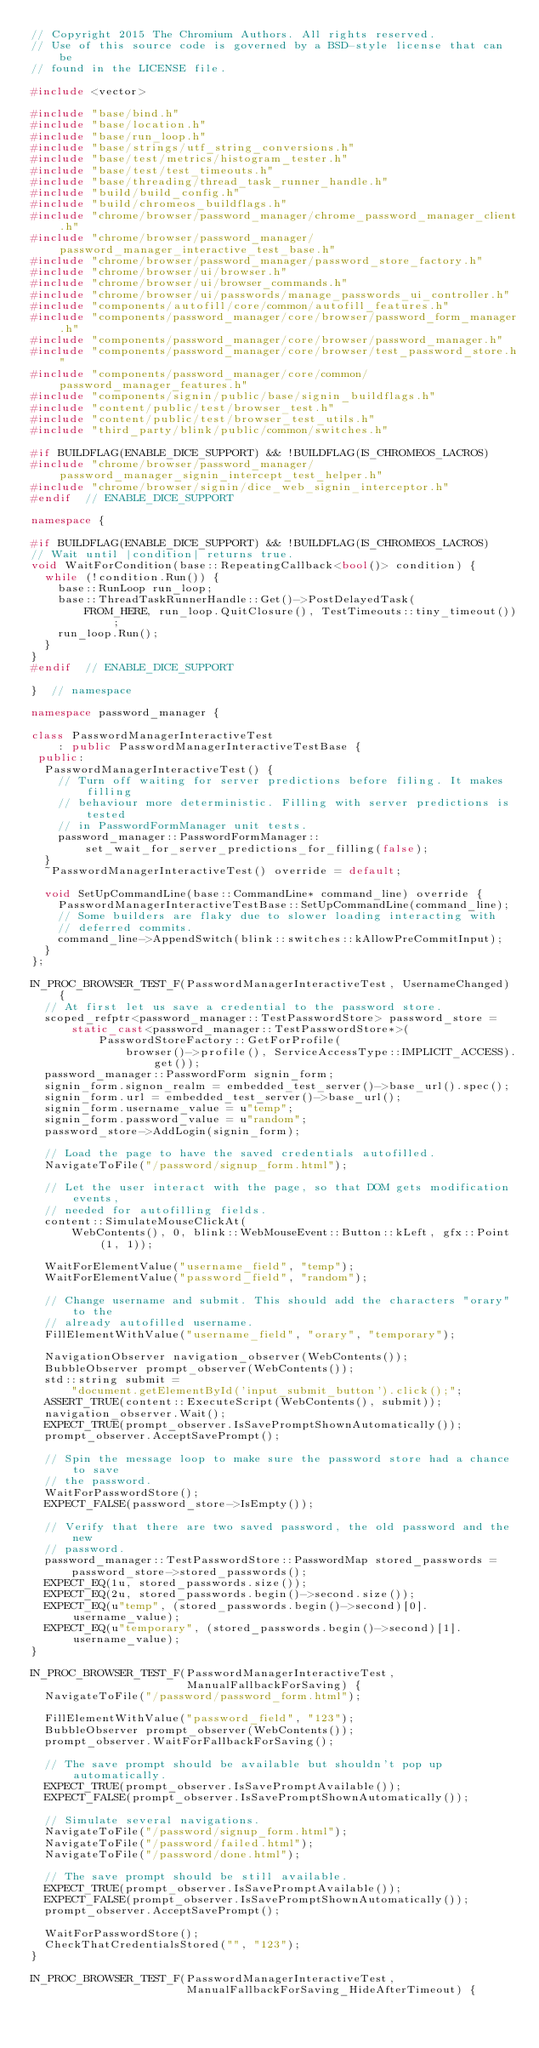<code> <loc_0><loc_0><loc_500><loc_500><_C++_>// Copyright 2015 The Chromium Authors. All rights reserved.
// Use of this source code is governed by a BSD-style license that can be
// found in the LICENSE file.

#include <vector>

#include "base/bind.h"
#include "base/location.h"
#include "base/run_loop.h"
#include "base/strings/utf_string_conversions.h"
#include "base/test/metrics/histogram_tester.h"
#include "base/test/test_timeouts.h"
#include "base/threading/thread_task_runner_handle.h"
#include "build/build_config.h"
#include "build/chromeos_buildflags.h"
#include "chrome/browser/password_manager/chrome_password_manager_client.h"
#include "chrome/browser/password_manager/password_manager_interactive_test_base.h"
#include "chrome/browser/password_manager/password_store_factory.h"
#include "chrome/browser/ui/browser.h"
#include "chrome/browser/ui/browser_commands.h"
#include "chrome/browser/ui/passwords/manage_passwords_ui_controller.h"
#include "components/autofill/core/common/autofill_features.h"
#include "components/password_manager/core/browser/password_form_manager.h"
#include "components/password_manager/core/browser/password_manager.h"
#include "components/password_manager/core/browser/test_password_store.h"
#include "components/password_manager/core/common/password_manager_features.h"
#include "components/signin/public/base/signin_buildflags.h"
#include "content/public/test/browser_test.h"
#include "content/public/test/browser_test_utils.h"
#include "third_party/blink/public/common/switches.h"

#if BUILDFLAG(ENABLE_DICE_SUPPORT) && !BUILDFLAG(IS_CHROMEOS_LACROS)
#include "chrome/browser/password_manager/password_manager_signin_intercept_test_helper.h"
#include "chrome/browser/signin/dice_web_signin_interceptor.h"
#endif  // ENABLE_DICE_SUPPORT

namespace {

#if BUILDFLAG(ENABLE_DICE_SUPPORT) && !BUILDFLAG(IS_CHROMEOS_LACROS)
// Wait until |condition| returns true.
void WaitForCondition(base::RepeatingCallback<bool()> condition) {
  while (!condition.Run()) {
    base::RunLoop run_loop;
    base::ThreadTaskRunnerHandle::Get()->PostDelayedTask(
        FROM_HERE, run_loop.QuitClosure(), TestTimeouts::tiny_timeout());
    run_loop.Run();
  }
}
#endif  // ENABLE_DICE_SUPPORT

}  // namespace

namespace password_manager {

class PasswordManagerInteractiveTest
    : public PasswordManagerInteractiveTestBase {
 public:
  PasswordManagerInteractiveTest() {
    // Turn off waiting for server predictions before filing. It makes filling
    // behaviour more deterministic. Filling with server predictions is tested
    // in PasswordFormManager unit tests.
    password_manager::PasswordFormManager::
        set_wait_for_server_predictions_for_filling(false);
  }
  ~PasswordManagerInteractiveTest() override = default;

  void SetUpCommandLine(base::CommandLine* command_line) override {
    PasswordManagerInteractiveTestBase::SetUpCommandLine(command_line);
    // Some builders are flaky due to slower loading interacting with
    // deferred commits.
    command_line->AppendSwitch(blink::switches::kAllowPreCommitInput);
  }
};

IN_PROC_BROWSER_TEST_F(PasswordManagerInteractiveTest, UsernameChanged) {
  // At first let us save a credential to the password store.
  scoped_refptr<password_manager::TestPasswordStore> password_store =
      static_cast<password_manager::TestPasswordStore*>(
          PasswordStoreFactory::GetForProfile(
              browser()->profile(), ServiceAccessType::IMPLICIT_ACCESS).get());
  password_manager::PasswordForm signin_form;
  signin_form.signon_realm = embedded_test_server()->base_url().spec();
  signin_form.url = embedded_test_server()->base_url();
  signin_form.username_value = u"temp";
  signin_form.password_value = u"random";
  password_store->AddLogin(signin_form);

  // Load the page to have the saved credentials autofilled.
  NavigateToFile("/password/signup_form.html");

  // Let the user interact with the page, so that DOM gets modification events,
  // needed for autofilling fields.
  content::SimulateMouseClickAt(
      WebContents(), 0, blink::WebMouseEvent::Button::kLeft, gfx::Point(1, 1));

  WaitForElementValue("username_field", "temp");
  WaitForElementValue("password_field", "random");

  // Change username and submit. This should add the characters "orary" to the
  // already autofilled username.
  FillElementWithValue("username_field", "orary", "temporary");

  NavigationObserver navigation_observer(WebContents());
  BubbleObserver prompt_observer(WebContents());
  std::string submit =
      "document.getElementById('input_submit_button').click();";
  ASSERT_TRUE(content::ExecuteScript(WebContents(), submit));
  navigation_observer.Wait();
  EXPECT_TRUE(prompt_observer.IsSavePromptShownAutomatically());
  prompt_observer.AcceptSavePrompt();

  // Spin the message loop to make sure the password store had a chance to save
  // the password.
  WaitForPasswordStore();
  EXPECT_FALSE(password_store->IsEmpty());

  // Verify that there are two saved password, the old password and the new
  // password.
  password_manager::TestPasswordStore::PasswordMap stored_passwords =
      password_store->stored_passwords();
  EXPECT_EQ(1u, stored_passwords.size());
  EXPECT_EQ(2u, stored_passwords.begin()->second.size());
  EXPECT_EQ(u"temp", (stored_passwords.begin()->second)[0].username_value);
  EXPECT_EQ(u"temporary", (stored_passwords.begin()->second)[1].username_value);
}

IN_PROC_BROWSER_TEST_F(PasswordManagerInteractiveTest,
                       ManualFallbackForSaving) {
  NavigateToFile("/password/password_form.html");

  FillElementWithValue("password_field", "123");
  BubbleObserver prompt_observer(WebContents());
  prompt_observer.WaitForFallbackForSaving();

  // The save prompt should be available but shouldn't pop up automatically.
  EXPECT_TRUE(prompt_observer.IsSavePromptAvailable());
  EXPECT_FALSE(prompt_observer.IsSavePromptShownAutomatically());

  // Simulate several navigations.
  NavigateToFile("/password/signup_form.html");
  NavigateToFile("/password/failed.html");
  NavigateToFile("/password/done.html");

  // The save prompt should be still available.
  EXPECT_TRUE(prompt_observer.IsSavePromptAvailable());
  EXPECT_FALSE(prompt_observer.IsSavePromptShownAutomatically());
  prompt_observer.AcceptSavePrompt();

  WaitForPasswordStore();
  CheckThatCredentialsStored("", "123");
}

IN_PROC_BROWSER_TEST_F(PasswordManagerInteractiveTest,
                       ManualFallbackForSaving_HideAfterTimeout) {</code> 